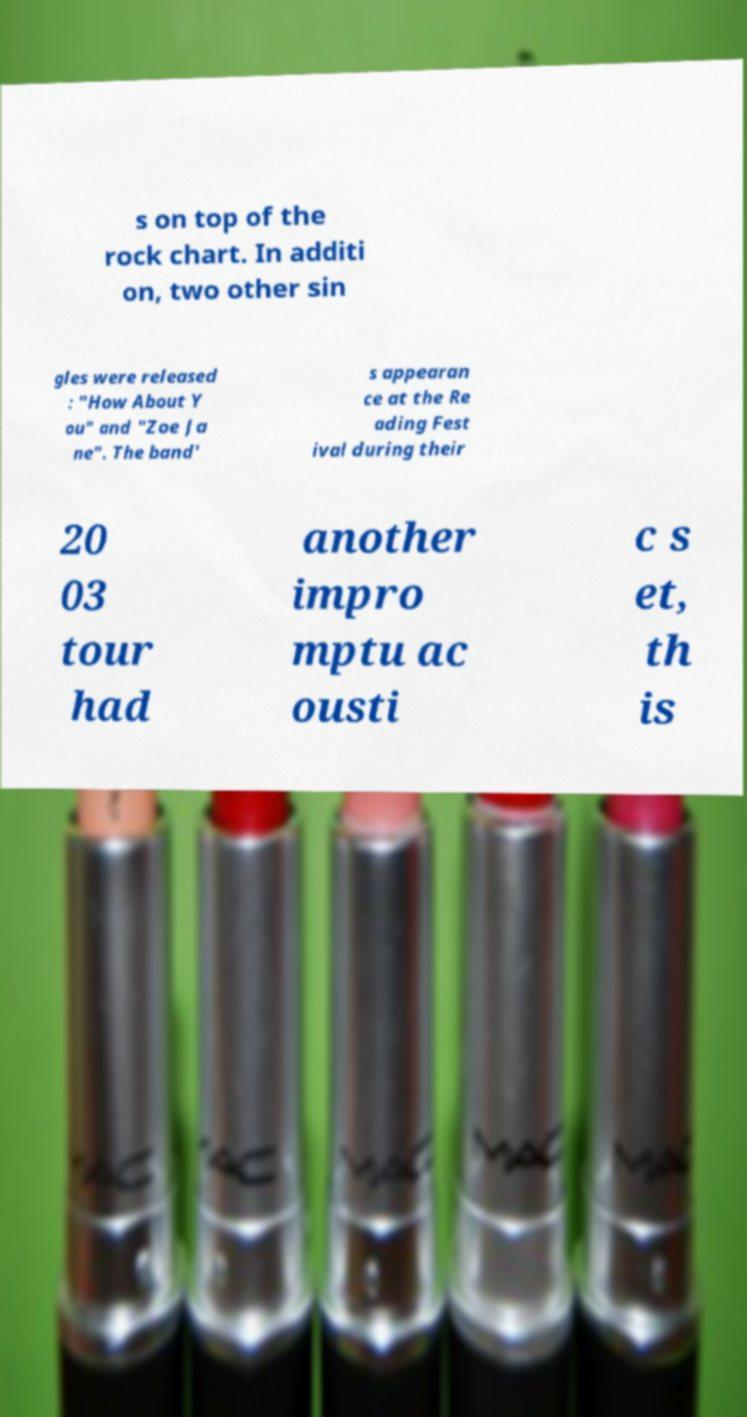Please read and relay the text visible in this image. What does it say? s on top of the rock chart. In additi on, two other sin gles were released : "How About Y ou" and "Zoe Ja ne". The band' s appearan ce at the Re ading Fest ival during their 20 03 tour had another impro mptu ac ousti c s et, th is 